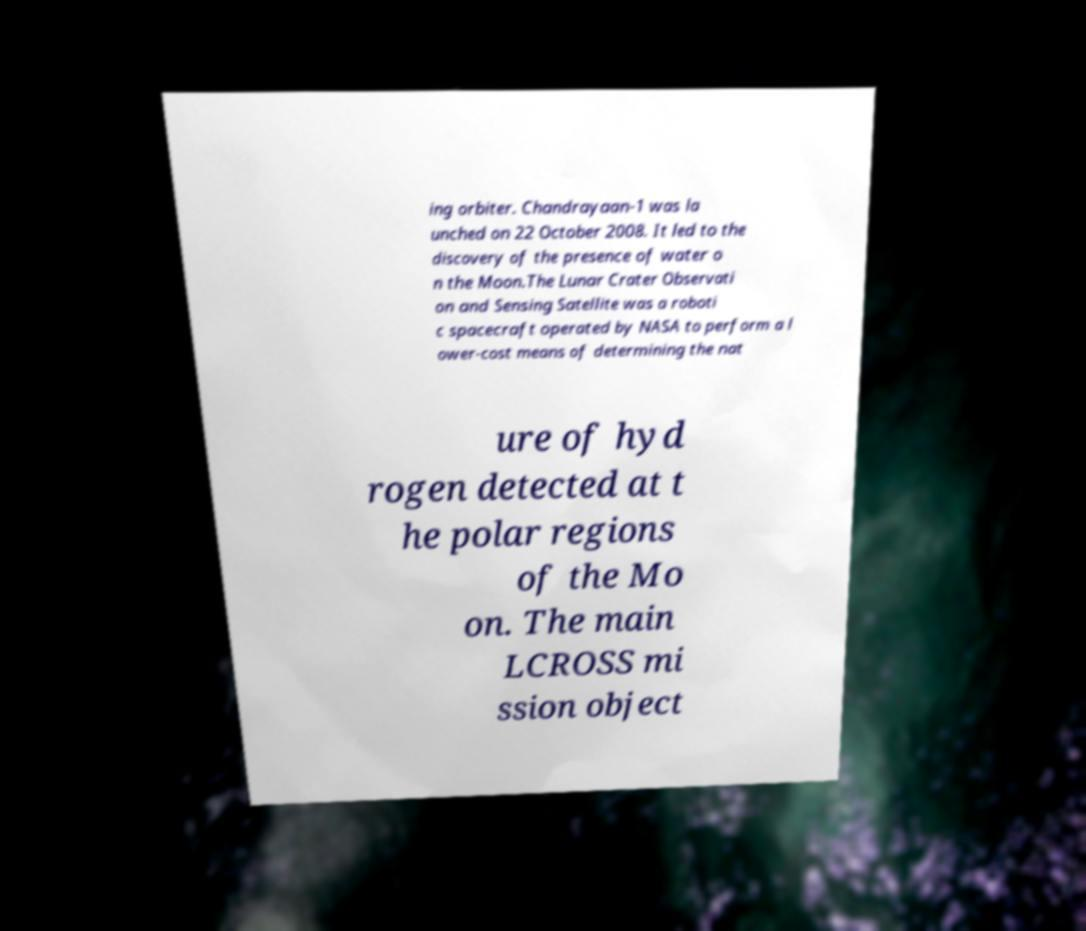Could you extract and type out the text from this image? ing orbiter. Chandrayaan-1 was la unched on 22 October 2008. It led to the discovery of the presence of water o n the Moon.The Lunar Crater Observati on and Sensing Satellite was a roboti c spacecraft operated by NASA to perform a l ower-cost means of determining the nat ure of hyd rogen detected at t he polar regions of the Mo on. The main LCROSS mi ssion object 